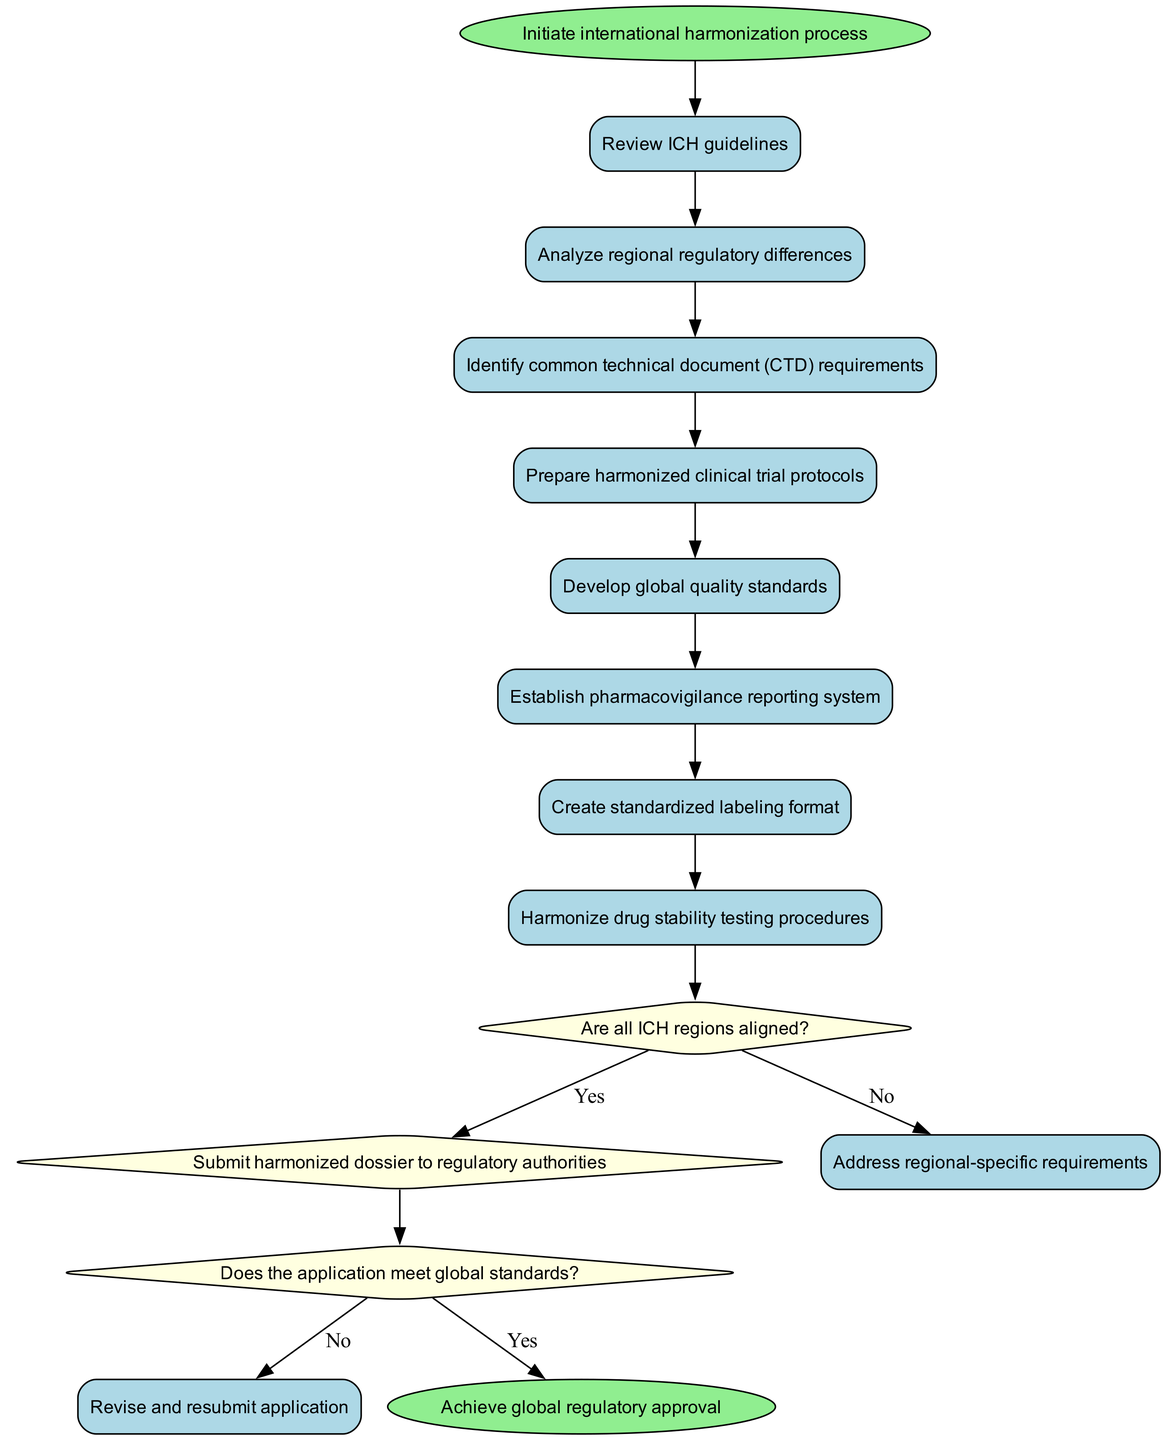What is the first activity in the diagram? The first activity listed in the diagram is "Review ICH guidelines". This is derived directly from the sequence of activities that follow the start node, where "Review ICH guidelines" is the first one mentioned.
Answer: Review ICH guidelines How many activities are present in the diagram? The diagram contains eight activities. This can be counted from the activities list provided in the data, which clearly enumerates each of them.
Answer: 8 What happens if all ICH regions are aligned? If all ICH regions are aligned, the flow proceeds to "Submit harmonized dossier to regulatory authorities". This is indicated by the line that flows from the decision node for alignment to the first flow node.
Answer: Submit harmonized dossier to regulatory authorities What is the action taken after addressing regional-specific requirements? After addressing regional-specific requirements, the next action is to "Revise and resubmit application". This follows the flow structure from the decision made regarding the global standards.
Answer: Revise and resubmit application What is the last node in the diagram? The last node in the diagram is "Achieve global regulatory approval". This represents the outcome of successfully navigating through the processes and flows defined in the activity diagram.
Answer: Achieve global regulatory approval If the application does not meet global standards, what is the next step? If the application does not meet global standards, the next step is to "Revise and resubmit application". The flow shows this direct connection following that decision.
Answer: Revise and resubmit application Which activity involves developing quality criteria? The activity that involves developing quality criteria is "Develop global quality standards". This is one of the activities specified in the list of processes to be undertaken.
Answer: Develop global quality standards How many decision points are in the diagram? There are two decision points in the diagram. This is confirmed by the list of decisions provided, which includes "Are all ICH regions aligned?" and "Does the application meet global standards?".
Answer: 2 